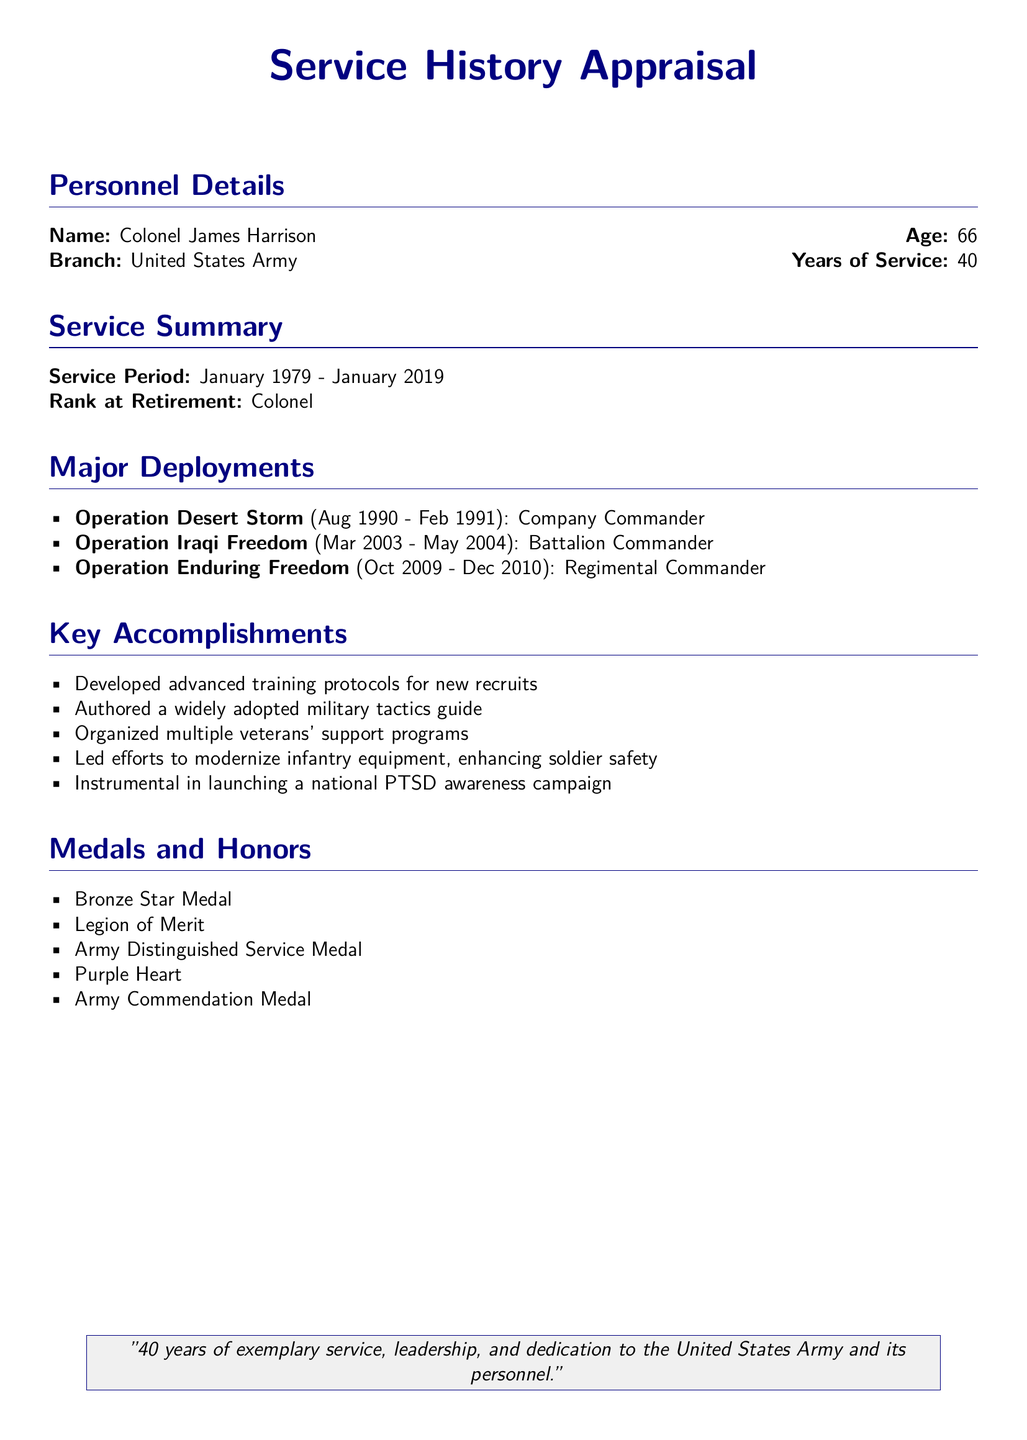what is the name of the individual? The document provides the name of the individual as Colonel James Harrison.
Answer: Colonel James Harrison what is the total number of years served? The years of service are specified in the document as 40.
Answer: 40 which operation was Colonel Harrison a Company Commander? The document mentions that Colonel Harrison served as a Company Commander during Operation Desert Storm.
Answer: Operation Desert Storm what medal is awarded for distinguished service? The document lists the Army Distinguished Service Medal as one of the honors received.
Answer: Army Distinguished Service Medal what key accomplishment involved modernizing equipment? The document states that Colonel Harrison led efforts to modernize infantry equipment.
Answer: Modernize infantry equipment how many major deployments are listed? The document enumerates a total of three major deployments.
Answer: 3 which campaign was Colonel Harrison instrumental in launching? The document indicates he was instrumental in launching a national PTSD awareness campaign.
Answer: National PTSD awareness campaign what rank did Colonel Harrison retire at? Colonel Harrison's rank at retirement is specified in the document as Colonel.
Answer: Colonel what year did Colonel Harrison's service begin? The document states that Colonel Harrison began his service in January 1979.
Answer: January 1979 